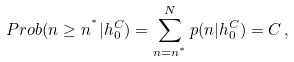<formula> <loc_0><loc_0><loc_500><loc_500>P r o b ( n \geq n ^ { ^ { * } } | h _ { 0 } ^ { C } ) = \sum _ { n = n ^ { ^ { * } } } ^ { N } p ( n | h _ { 0 } ^ { C } ) = C \, ,</formula> 